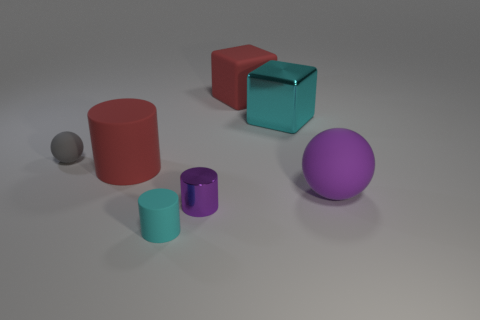Add 1 gray matte things. How many objects exist? 8 Subtract all spheres. How many objects are left? 5 Subtract 0 brown spheres. How many objects are left? 7 Subtract all big cyan cubes. Subtract all large balls. How many objects are left? 5 Add 3 objects. How many objects are left? 10 Add 3 big green matte objects. How many big green matte objects exist? 3 